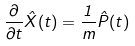Convert formula to latex. <formula><loc_0><loc_0><loc_500><loc_500>\frac { \partial } { \partial t } { { \hat { X } } } ( t ) = \frac { 1 } { m } { { \hat { P } } } ( t )</formula> 